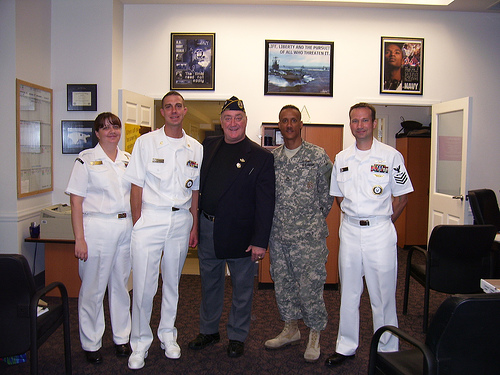<image>
Can you confirm if the man is behind the chair? Yes. From this viewpoint, the man is positioned behind the chair, with the chair partially or fully occluding the man. Is the man on the poster? No. The man is not positioned on the poster. They may be near each other, but the man is not supported by or resting on top of the poster. 